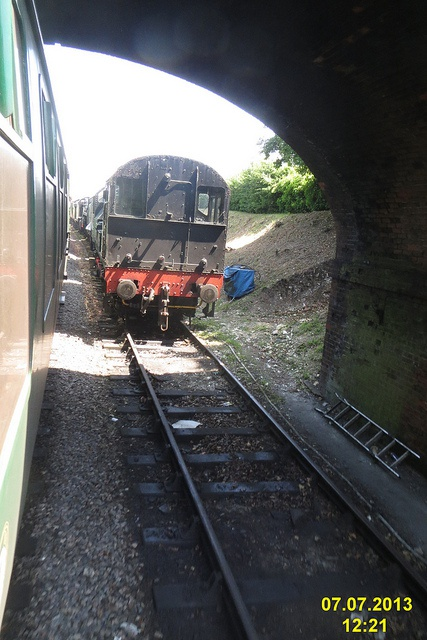Describe the objects in this image and their specific colors. I can see train in turquoise, white, gray, tan, and darkgray tones and train in turquoise, gray, black, and darkgray tones in this image. 